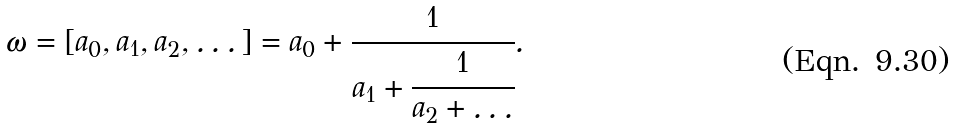<formula> <loc_0><loc_0><loc_500><loc_500>\omega = [ a _ { 0 } , a _ { 1 } , a _ { 2 } , \dots ] = a _ { 0 } + \cfrac { 1 } { a _ { 1 } + \cfrac { 1 } { a _ { 2 } + \dots } } .</formula> 